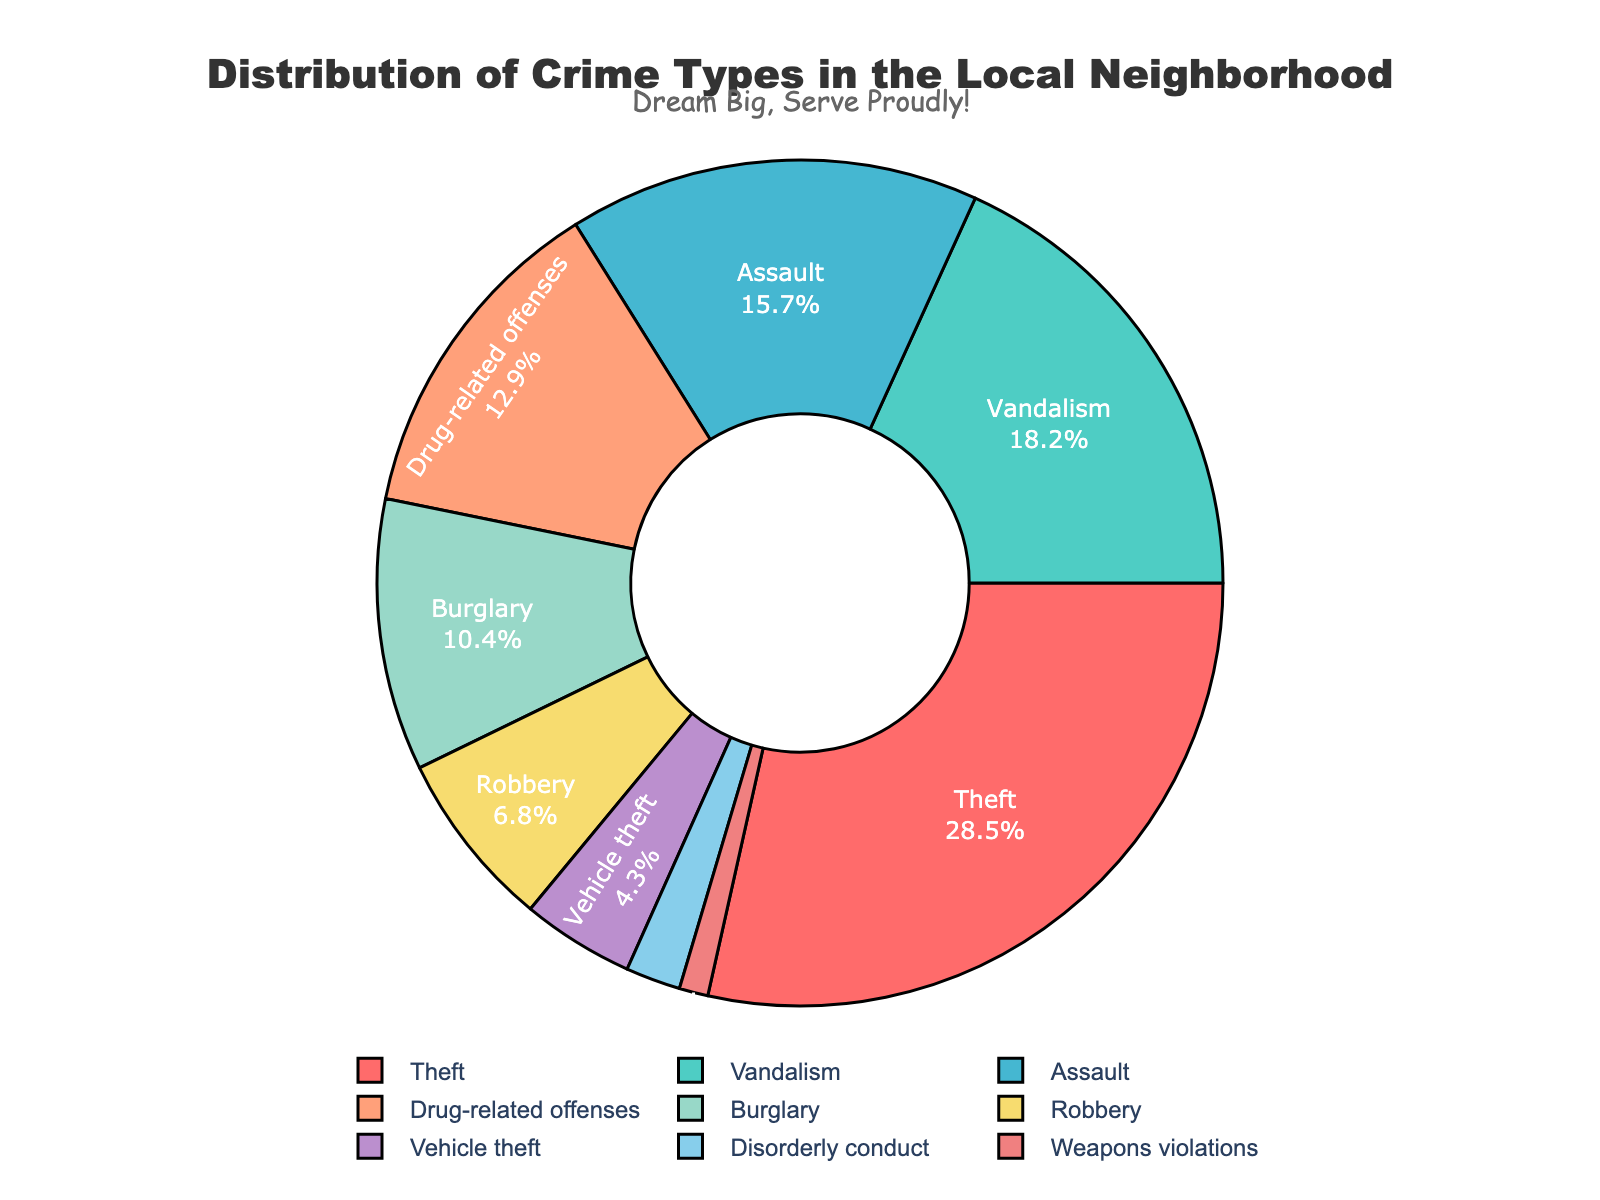What's the most common crime type in the local neighborhood? The most common crime type is represented by the largest slice of the pie chart, which is labeled 'Theft' with 28.5%.
Answer: Theft Which two crime types combined have a higher percentage than drug-related offenses? Drug-related offenses are at 12.9%. The next two smallest slices are vehicle theft (4.3%) and disorderly conduct (2.1%), whose combined percentage is 6.4%, which is lower. The two slices vandalism (18.2%) and burglary (10.4%) combined equal 28.6%, which is higher.
Answer: Vandalism and Burglary What's the difference in percentage between assaults and robberies? Assault has a percentage of 15.7% and robbery has 6.8%. Subtracting robbery from assault gives 15.7% - 6.8% = 8.9%.
Answer: 8.9% Which crime type represents the smallest slice of the pie chart? The smallest slice of the pie chart is labeled 'Weapons violations' with 1.1%.
Answer: Weapons violations Is the sum of assault and vandalism greater than the sum of theft and burglary? The percentage of assault (15.7%) and vandalism (18.2%) sum to 33.9%. The percentage of theft (28.5%) and burglary (10.4%) sum to 38.9%. Since 33.9% is less than 38.9%, the sum is not greater.
Answer: No What color represents robbery on the pie chart? The color associated with robbery is a slice labeled 'Robbery' and is colored in a shade of yellow.
Answer: Yellow Are there any crime types with a percentage less than 2%? Checking each slice, disorderly conduct at 2.1% and weapons violations at 1.1% are visible. Weapons violations are less than 2%.
Answer: Yes What is the combined percentage of vandalism, robbery, and vehicle theft? Vandalism has 18.2%, robbery has 6.8%, and vehicle theft has 4.3%. Adding these up gives 18.2% + 6.8% + 4.3% = 29.3%.
Answer: 29.3% Which is more prevalent, drug-related offenses or burglary? Drug-related offenses are 12.9% and burglary is 10.4%. 12.9% is greater than 10.4%.
Answer: Drug-related offenses How much larger is the percentage of theft compared to vehicle theft? Theft has 28.5% and vehicle theft has 4.3%. Subtracting vehicle theft from theft gives 28.5% - 4.3% = 24.2%.
Answer: 24.2% 